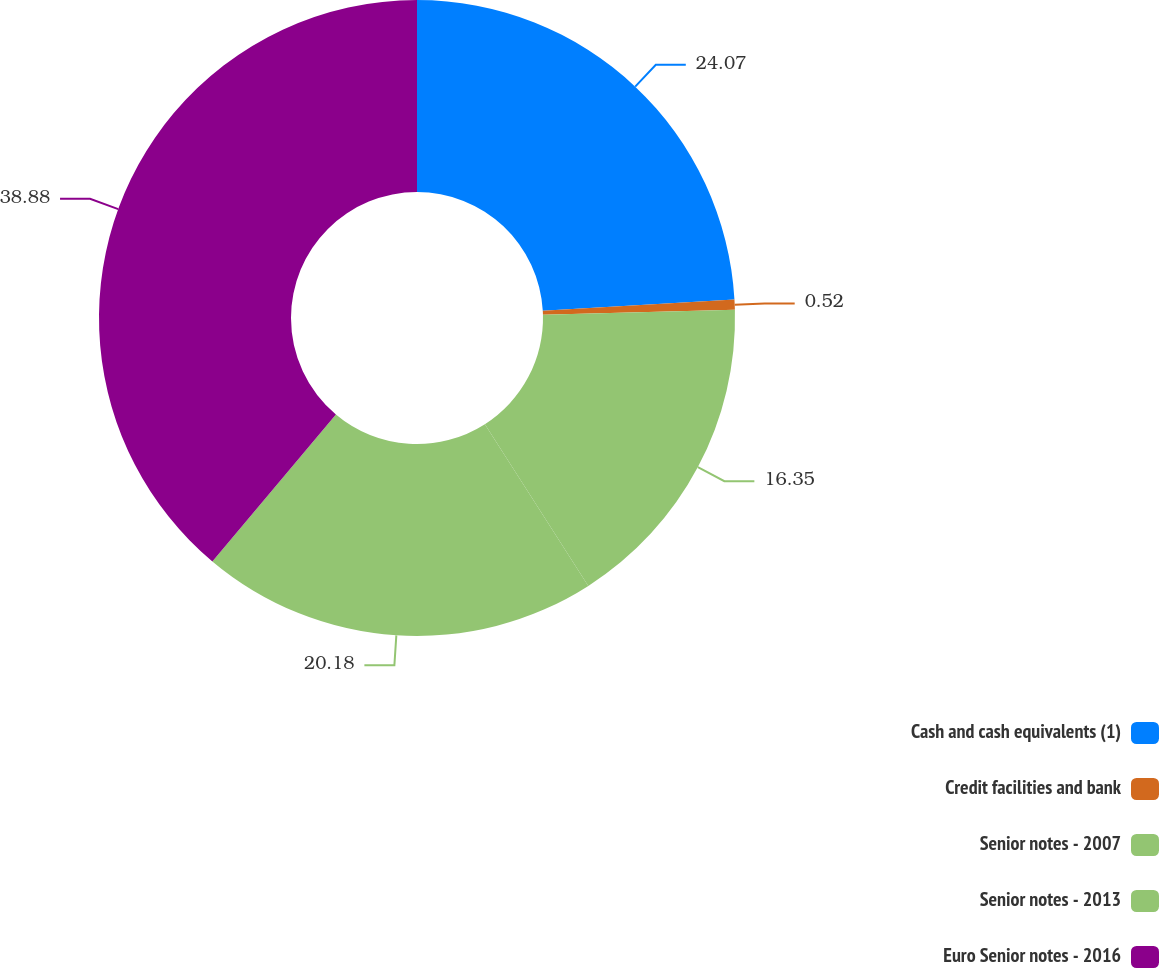Convert chart. <chart><loc_0><loc_0><loc_500><loc_500><pie_chart><fcel>Cash and cash equivalents (1)<fcel>Credit facilities and bank<fcel>Senior notes - 2007<fcel>Senior notes - 2013<fcel>Euro Senior notes - 2016<nl><fcel>24.07%<fcel>0.52%<fcel>16.35%<fcel>20.18%<fcel>38.87%<nl></chart> 